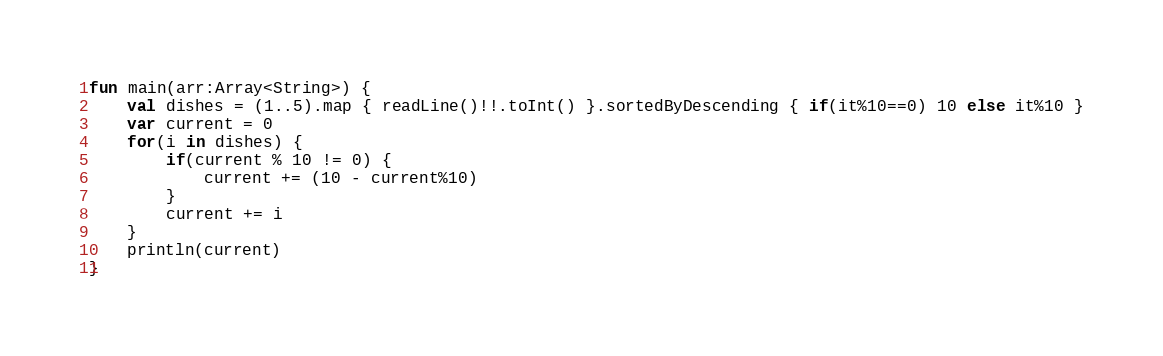<code> <loc_0><loc_0><loc_500><loc_500><_Kotlin_>fun main(arr:Array<String>) {
    val dishes = (1..5).map { readLine()!!.toInt() }.sortedByDescending { if(it%10==0) 10 else it%10 }
    var current = 0
    for(i in dishes) {
        if(current % 10 != 0) {
            current += (10 - current%10)
        }
        current += i
    }
    println(current)
}
</code> 